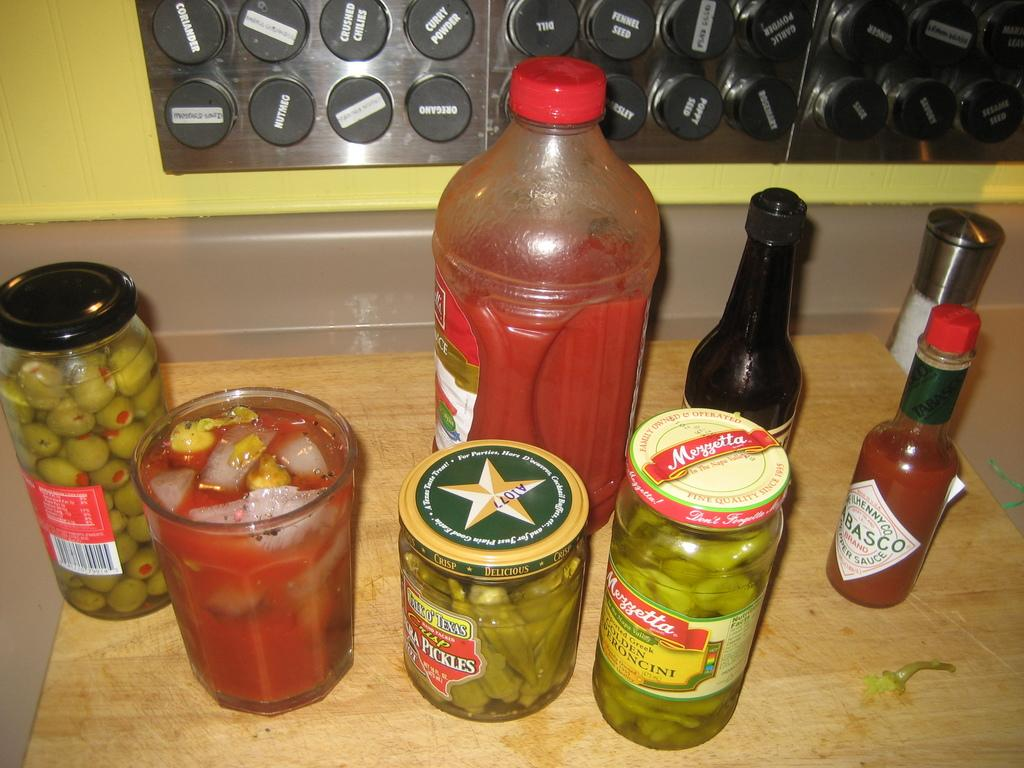What objects are on the table in the image? There are bottles, a glass, and boxes on the table. Can you describe the bottles on the table? The bottles are on the table, but their specific characteristics are not mentioned in the facts. What is the glass used for? The purpose of the glass is not mentioned in the facts, but it is likely used for drinking. How many boxes are on the table? The number of boxes on the table is not mentioned in the facts. What type of vegetable is growing on the table in the image? There is no vegetable growing on the table in the image. How do the dinosaurs say good-bye in the image? There are no dinosaurs present in the image, so they cannot say good-bye. 